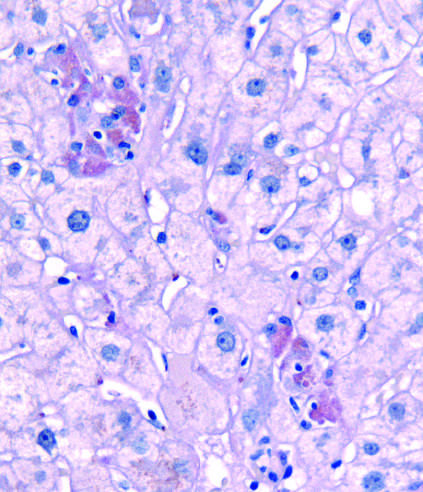what do clusters of pigmented hepatocytes with eosinophilic cytoplasm indicate?
Answer the question using a single word or phrase. Foci of hepatocytes undergoing necrosis 